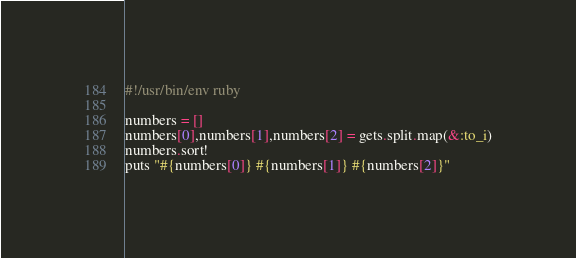Convert code to text. <code><loc_0><loc_0><loc_500><loc_500><_Ruby_>#!/usr/bin/env ruby

numbers = []
numbers[0],numbers[1],numbers[2] = gets.split.map(&:to_i)
numbers.sort!
puts "#{numbers[0]} #{numbers[1]} #{numbers[2]}"
</code> 